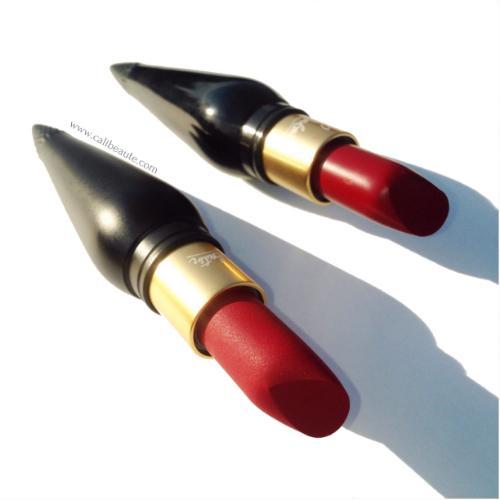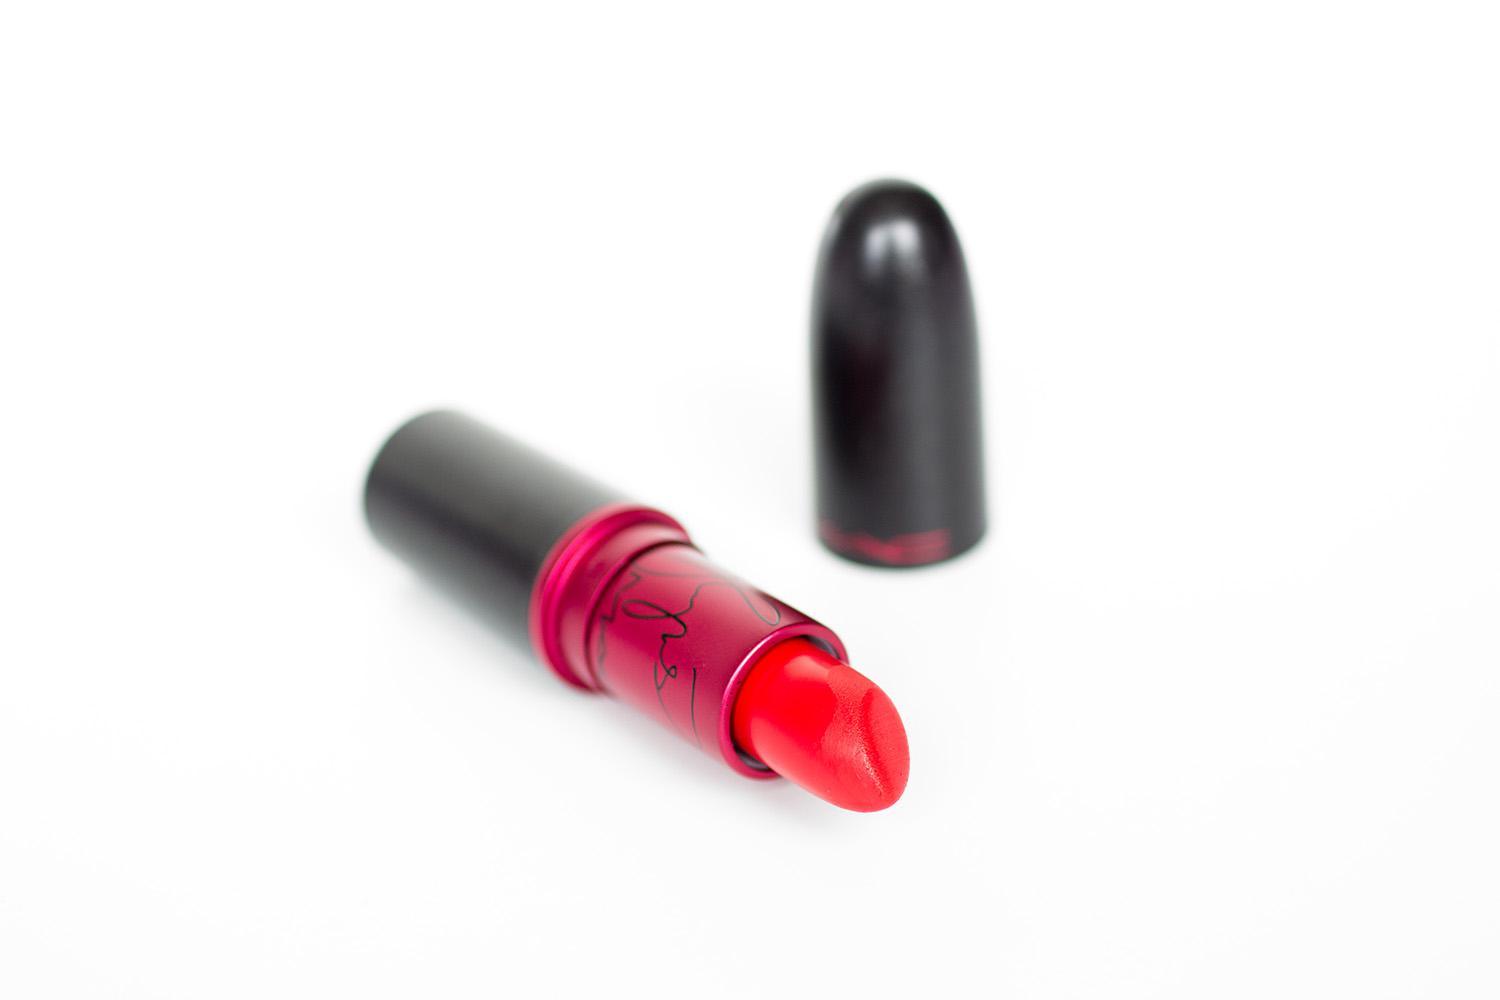The first image is the image on the left, the second image is the image on the right. Considering the images on both sides, is "A light pink lipstick is featured in both images." valid? Answer yes or no. No. 